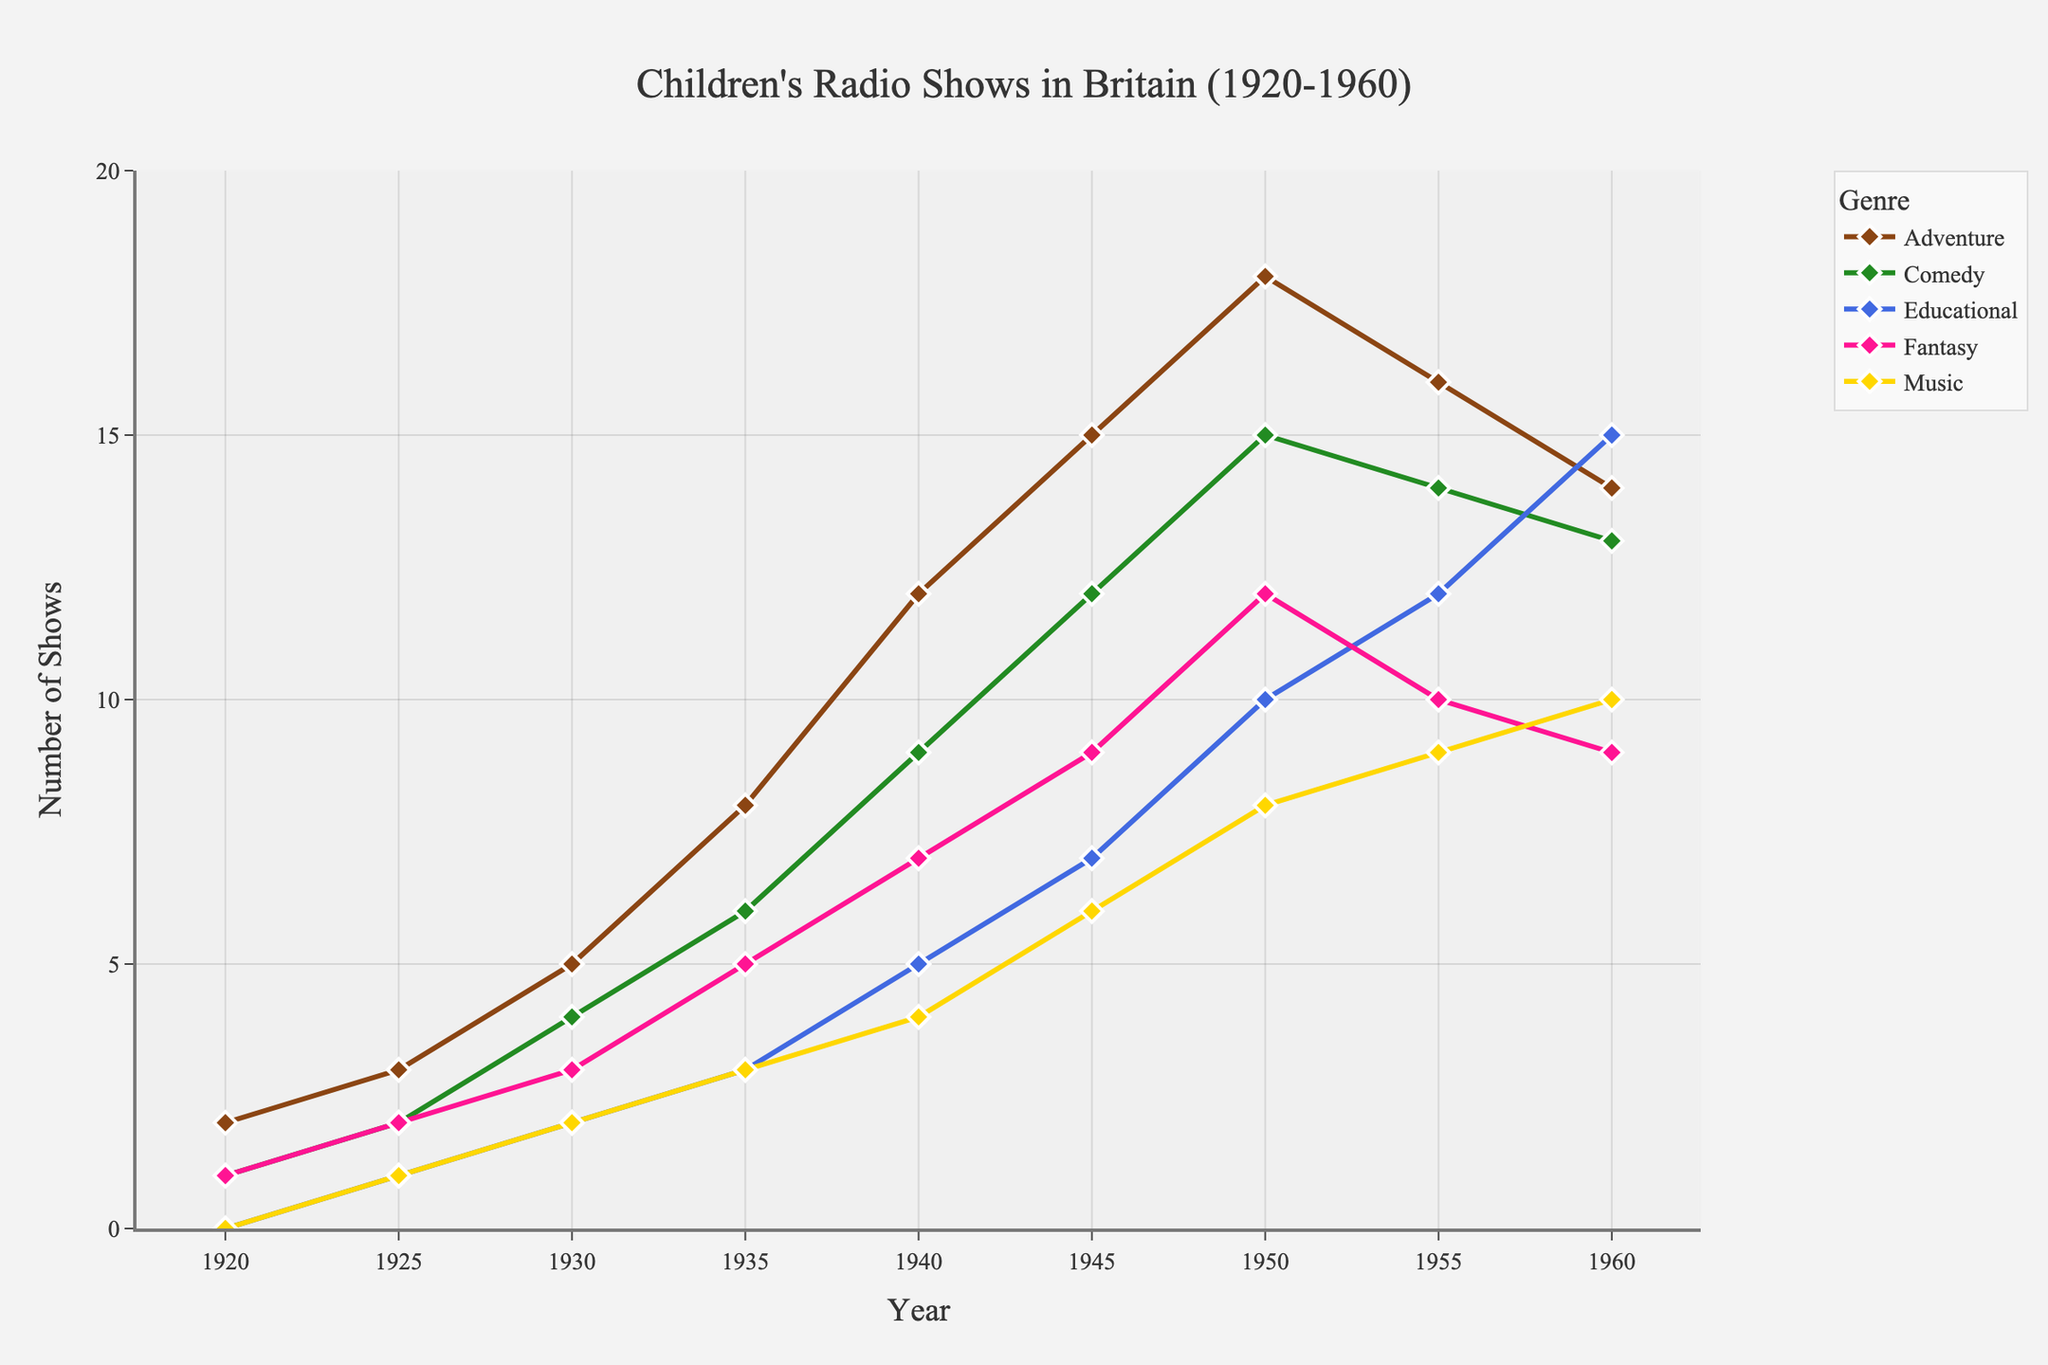What's the overall trend in the number of children's radio shows aired between 1920 and 1960? To determine the overall trend, we examine the data points across the years. For all genres (Adventure, Comedy, Educational, Fantasy, Music), there is a steady increase in the number of shows aired from 1920 up to around 1950. After 1950, there's a slight decline in some genres but mainly a continued moderate increase.
Answer: Increasing trend Which genre saw the highest number of shows aired in 1960? To find the genre with the highest number of shows in 1960, check the last year's data for each genre. Adventure had 14, Comedy 13, Educational 15, Fantasy 9, and Music 10. Educational has the highest number with 15 shows.
Answer: Educational How did the number of Adventure and Fantasy radio shows change from 1940 to 1950? To find the change, look at the data for Adventure and Fantasy in 1940 and 1950. For Adventure: 18 (1950) - 12 (1940) = 6. For Fantasy: 12 (1950) - 7 (1940) = 5. Adventure shows increased by 6, and Fantasy shows increased by 5.
Answer: Adventure: +6, Fantasy: +5 In which year did Comedy shows first exceed 10 per year? Check the data for Comedy across the years. Comedy exceeds 10 in 1945 with 12 shows for the first time.
Answer: 1945 Which genre experienced the largest percentage increase in the number of shows aired from 1920 to 1930? Calculate the percentage increase for each genre from 1920 to 1930. For Adventure: ((5-2)/2)*100 = 150%, Comedy: ((4-1)/1)*100 = 300%, Educational: ((2-0)/0)*100 = infinite, Fantasy: ((3-1)/1)*100=200%, Music: ((2-0)/0)*100 = infinite. Since both Educational and Music increased from zero, Comedy has the largest meaningful percentage increase of 300%.
Answer: Comedy Between which consecutive years did the number of Music shows see the greatest rise? Examine the changes year to year for the Music genre. The maximum increase is from 1945 to 1950 (8-6 = 2).
Answer: 1945 to 1950 What was the rate of increase in the number of Educational shows from 1945 to 1960? From 1945 to 1960, Educational shows increased from 7 to 15. The number of years is 15 (1960-1945). The rate is (15-7)/15 = 0.53 shows per year.
Answer: 0.53 shows per year How does the trend of Fantasy shows compare to Adventure shows throughout the period 1920-1960? Compare Adventure and Fantasy lines in the figure. Both genres increase steadily, with Adventure having a higher number overall. Both show a slight decline in later years but Adventure shows a steeper initial increase compared to Fantasy.
Answer: Adventure has a steeper increase, higher overall In which year did the number of Adventure shows reach its peak? Check the Adventure data for the highest value. The peak is in 1950 with 18 shows.
Answer: 1950 Which genre had the least significant change in the number of shows aired from 1950 to 1960? To determine the least significant change, check the difference in each genre: Adventure: 18-14=4, Comedy: 15-13=2, Educational: 10-15=5, Fantasy: 12-9=3, Music: 8-10=2. Comedy and Music had the smallest change, with a difference of 2 shows.
Answer: Comedy, Music 